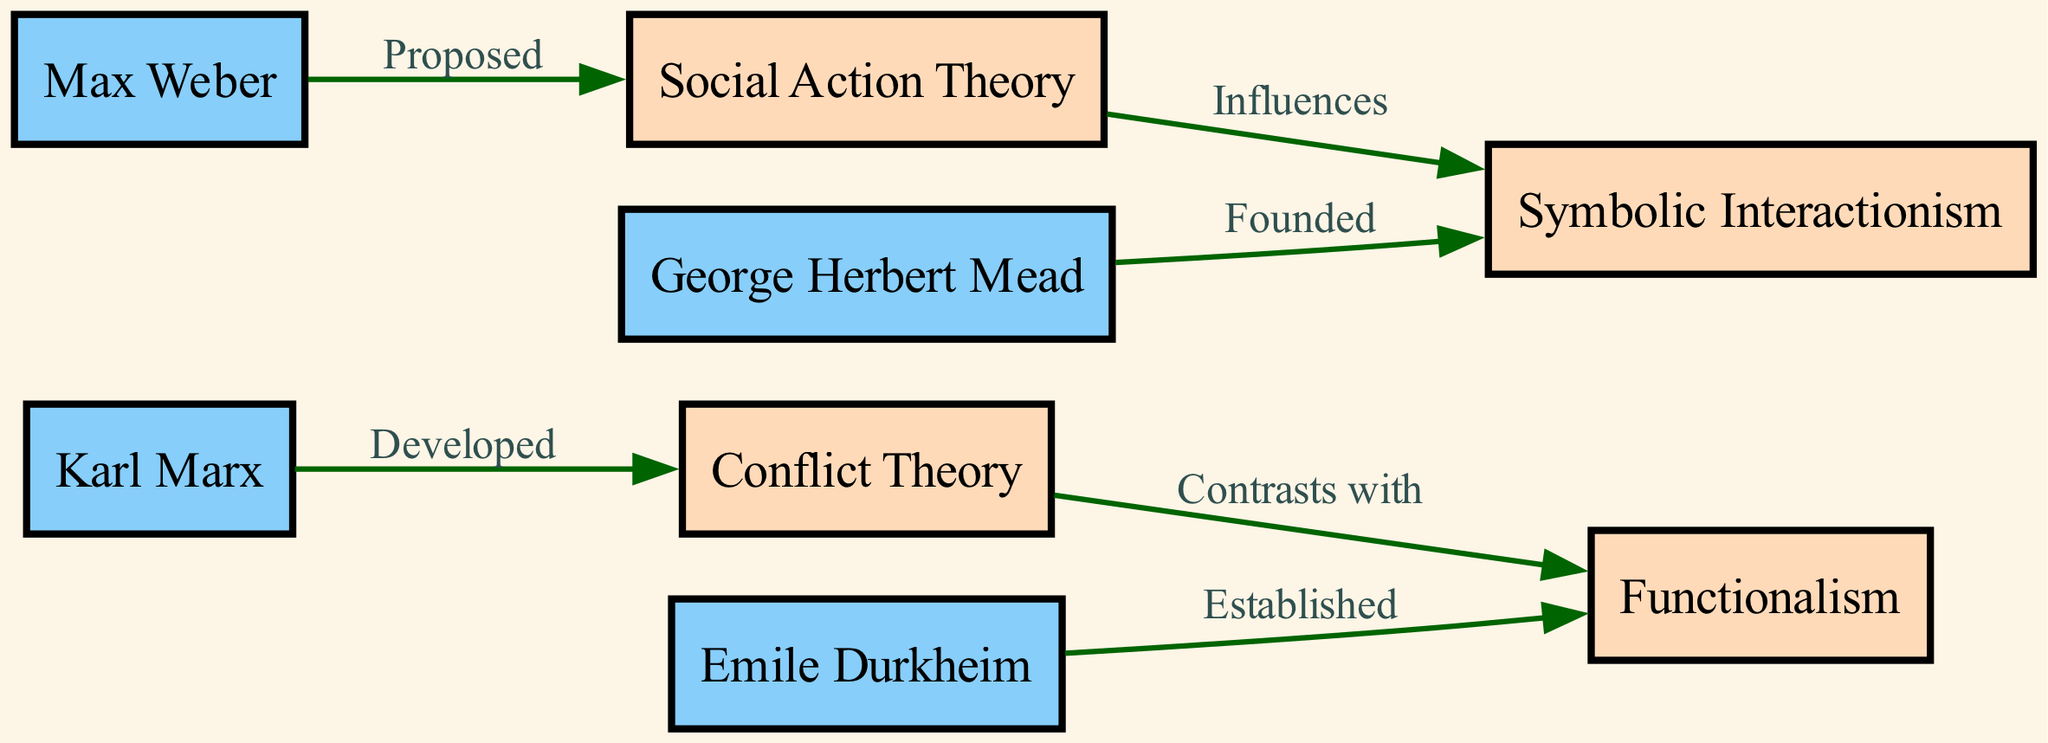What is the number of founders depicted in the diagram? Counting the nodes classified as "Founder," there are four: Karl Marx, Emile Durkheim, Max Weber, and George Herbert Mead.
Answer: 4 Which theory is associated with Karl Marx? The diagram indicates that Conflict Theory is developed by Karl Marx, as shown by the direct edge labeled "Developed" connecting his node to Conflict Theory.
Answer: Conflict Theory Which founder established Functionalism? Emile Durkheim is shown as the founder who established Functionalism, indicated by the direct edge labeled "Established" connecting Durkheim's node to Functionalism.
Answer: Emile Durkheim What relationship exists between Conflict Theory and Functionalism? The diagram states that Conflict Theory contrasts with Functionalism, indicated by the edge labeled "Contrasts with" connecting the two theories.
Answer: Contrasts with Which theory is influenced by Social Action Theory? The edge labeled "Influences" shows that Symbolic Interactionism is influenced by Social Action Theory, as indicated in the diagram.
Answer: Symbolic Interactionism How many edges are present in the diagram? By counting the connections between nodes, there are six edges shown in the diagram.
Answer: 6 Who is the founder of Symbolic Interactionism? The diagram labels George Herbert Mead as the founder of Symbolic Interactionism, as indicated by the edge labeled "Founded" connecting Mead to the theory.
Answer: George Herbert Mead What type of diagram is this? This diagram is a Social Science Diagram, which illustrates the interconnections between social theories and their founders.
Answer: Social Science Diagram 